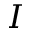Convert formula to latex. <formula><loc_0><loc_0><loc_500><loc_500>I</formula> 